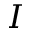Convert formula to latex. <formula><loc_0><loc_0><loc_500><loc_500>I</formula> 